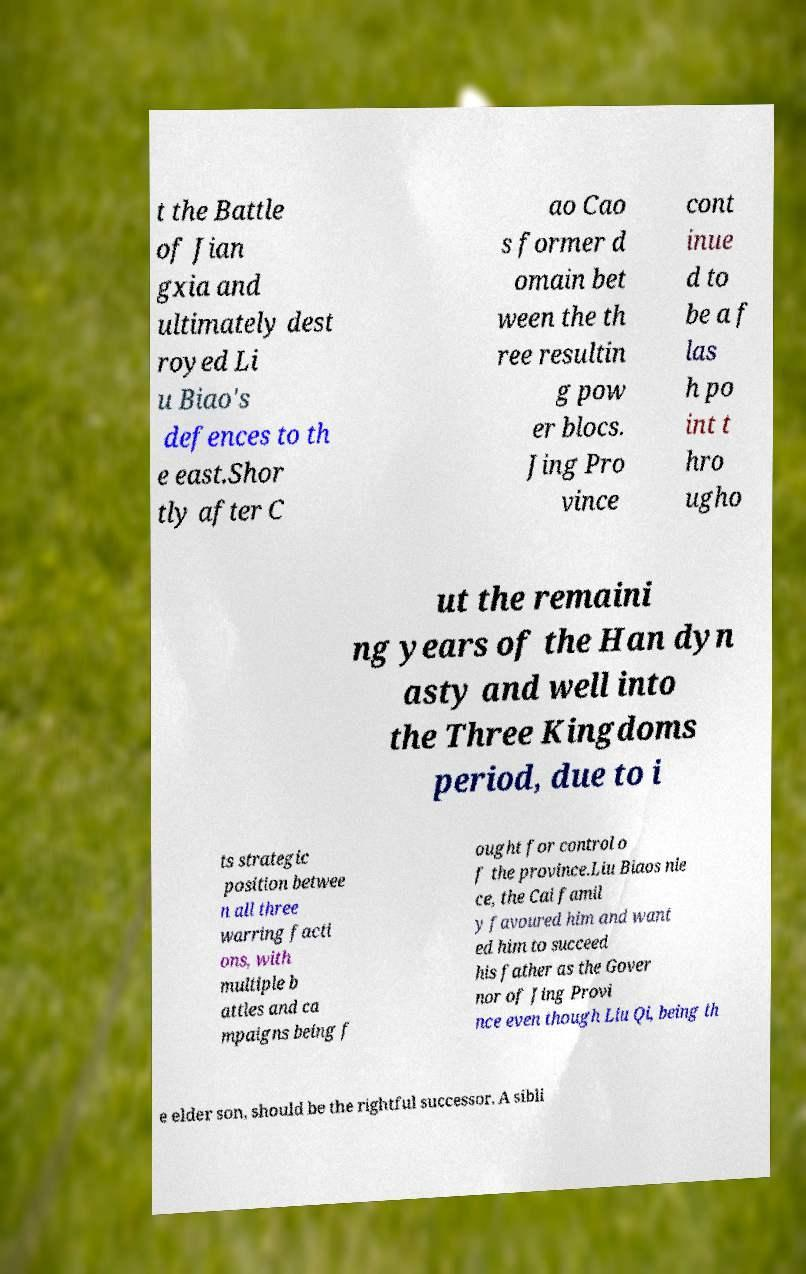Could you assist in decoding the text presented in this image and type it out clearly? t the Battle of Jian gxia and ultimately dest royed Li u Biao's defences to th e east.Shor tly after C ao Cao s former d omain bet ween the th ree resultin g pow er blocs. Jing Pro vince cont inue d to be a f las h po int t hro ugho ut the remaini ng years of the Han dyn asty and well into the Three Kingdoms period, due to i ts strategic position betwee n all three warring facti ons, with multiple b attles and ca mpaigns being f ought for control o f the province.Liu Biaos nie ce, the Cai famil y favoured him and want ed him to succeed his father as the Gover nor of Jing Provi nce even though Liu Qi, being th e elder son, should be the rightful successor. A sibli 